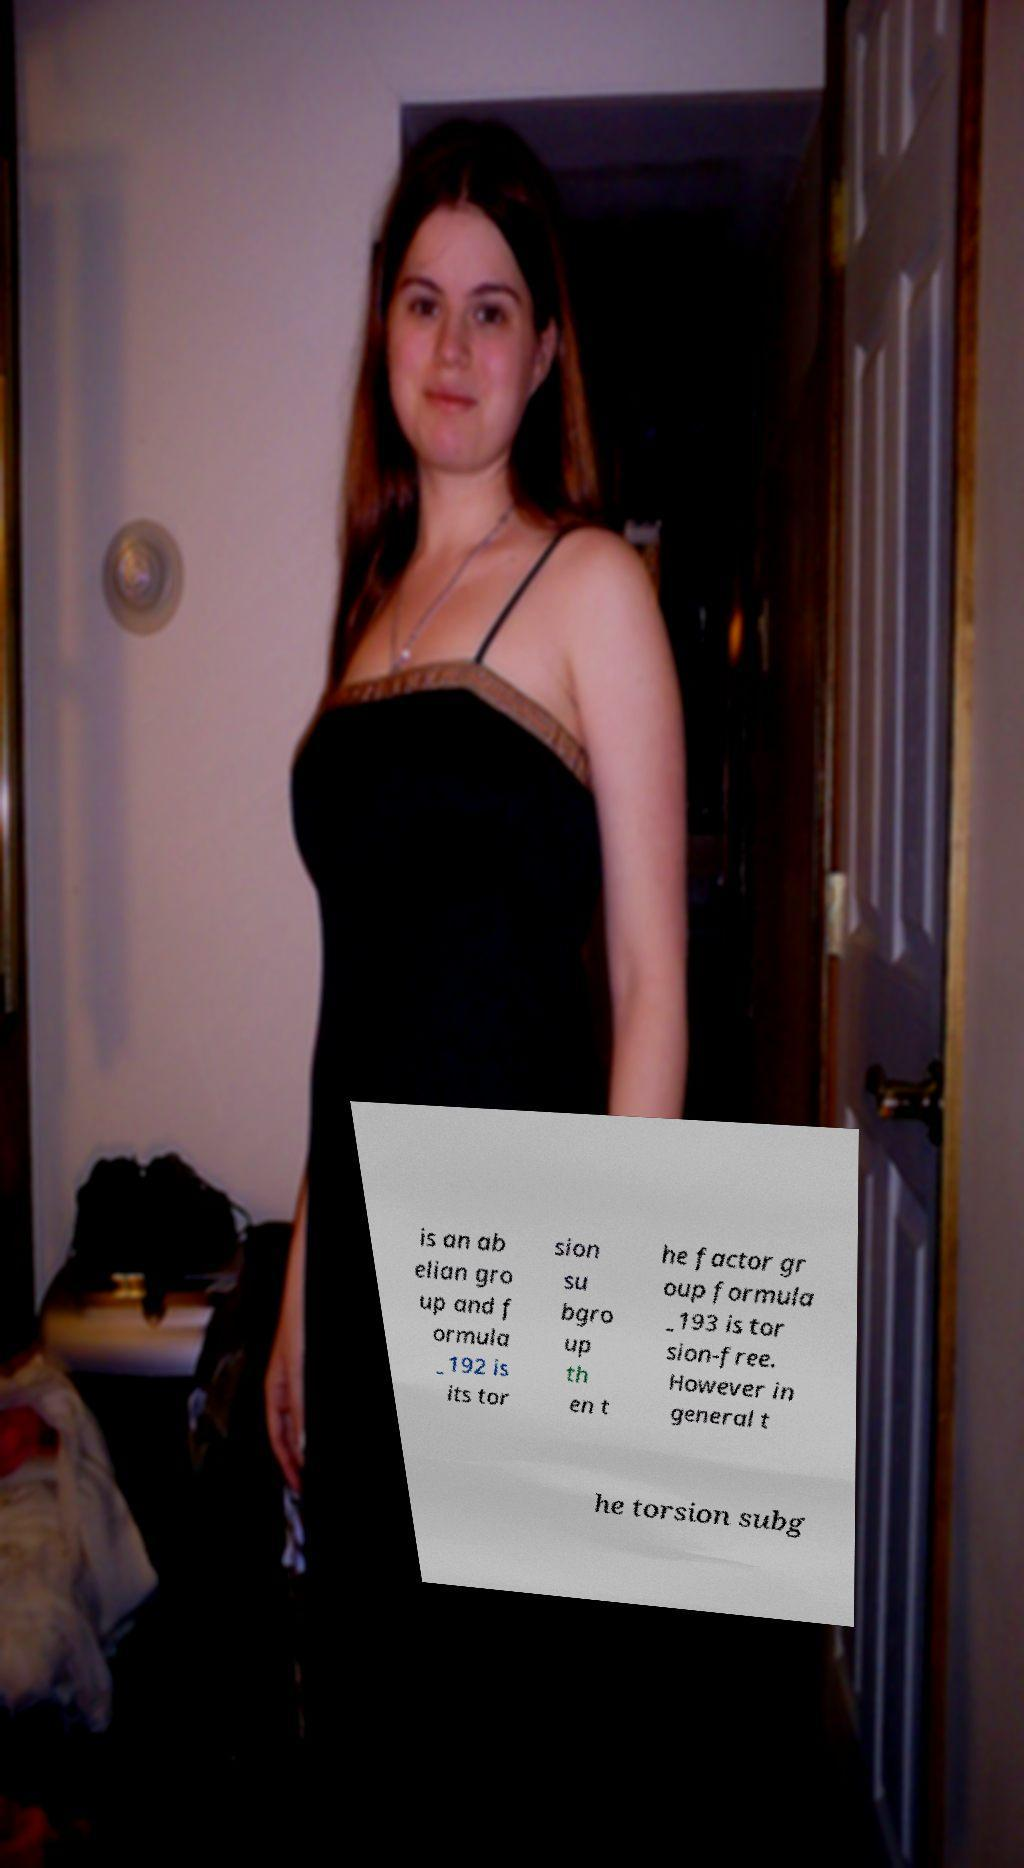What messages or text are displayed in this image? I need them in a readable, typed format. is an ab elian gro up and f ormula _192 is its tor sion su bgro up th en t he factor gr oup formula _193 is tor sion-free. However in general t he torsion subg 